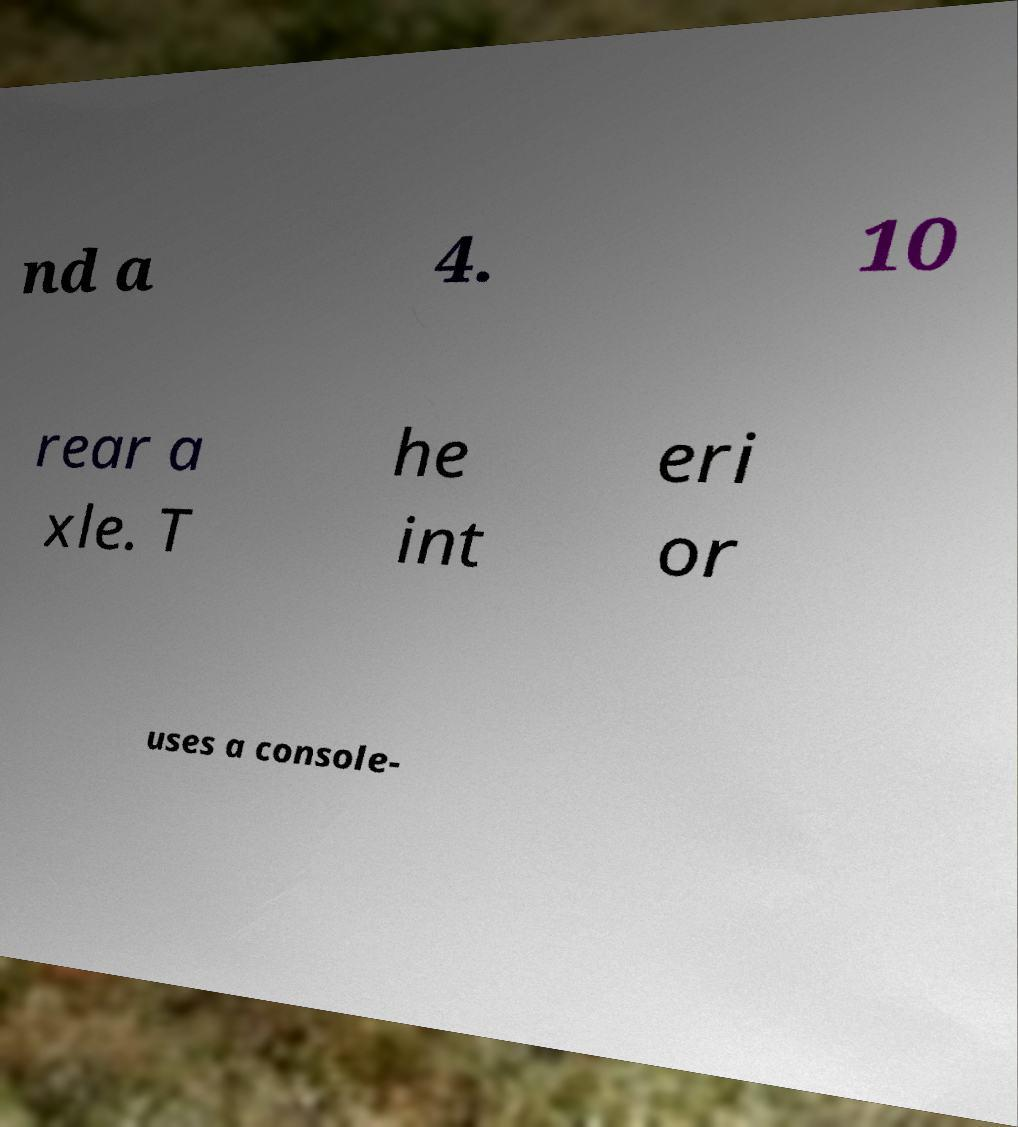What messages or text are displayed in this image? I need them in a readable, typed format. nd a 4. 10 rear a xle. T he int eri or uses a console- 